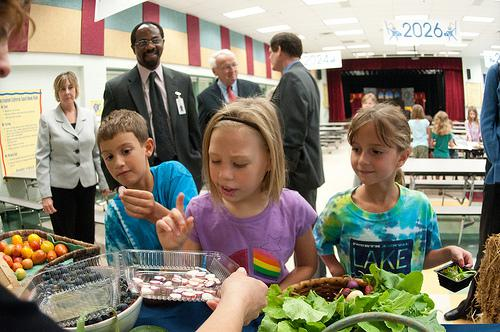Question: who is in the picture?
Choices:
A. A man.
B. Kids and adults.
C. A boy.
D. A judge.
Answer with the letter. Answer: B Question: what color is the mens suits?
Choices:
A. Black.
B. Gray.
C. Blue.
D. Silver.
Answer with the letter. Answer: B Question: where are the kids?
Choices:
A. In the playroom.
B. Standing at the table.
C. On the beach.
D. At school.
Answer with the letter. Answer: B Question: what is on the table?
Choices:
A. Vegetables.
B. Rice.
C. Apples.
D. Candles.
Answer with the letter. Answer: A Question: why are the kids standing?
Choices:
A. To look at the vegetables.
B. To watch a game.
C. To get food.
D. To line up.
Answer with the letter. Answer: A 